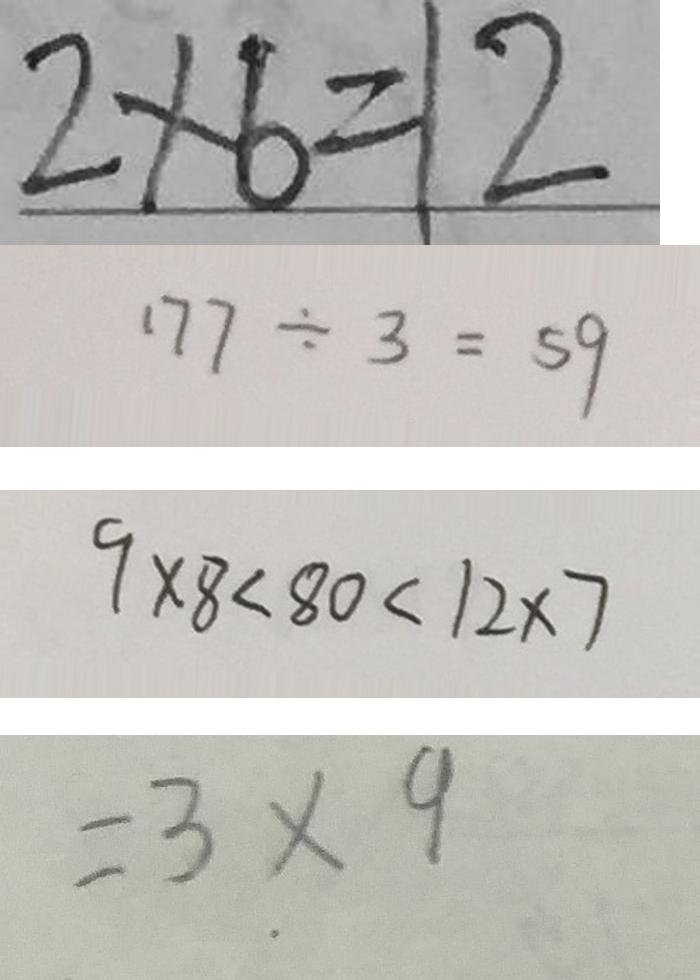Convert formula to latex. <formula><loc_0><loc_0><loc_500><loc_500>2 \times 6 = 1 2 
 1 7 7 \div 3 = 5 9 
 9 \times 8 < 8 0 < 1 2 \times 7 
 = 3 . \times 9</formula> 